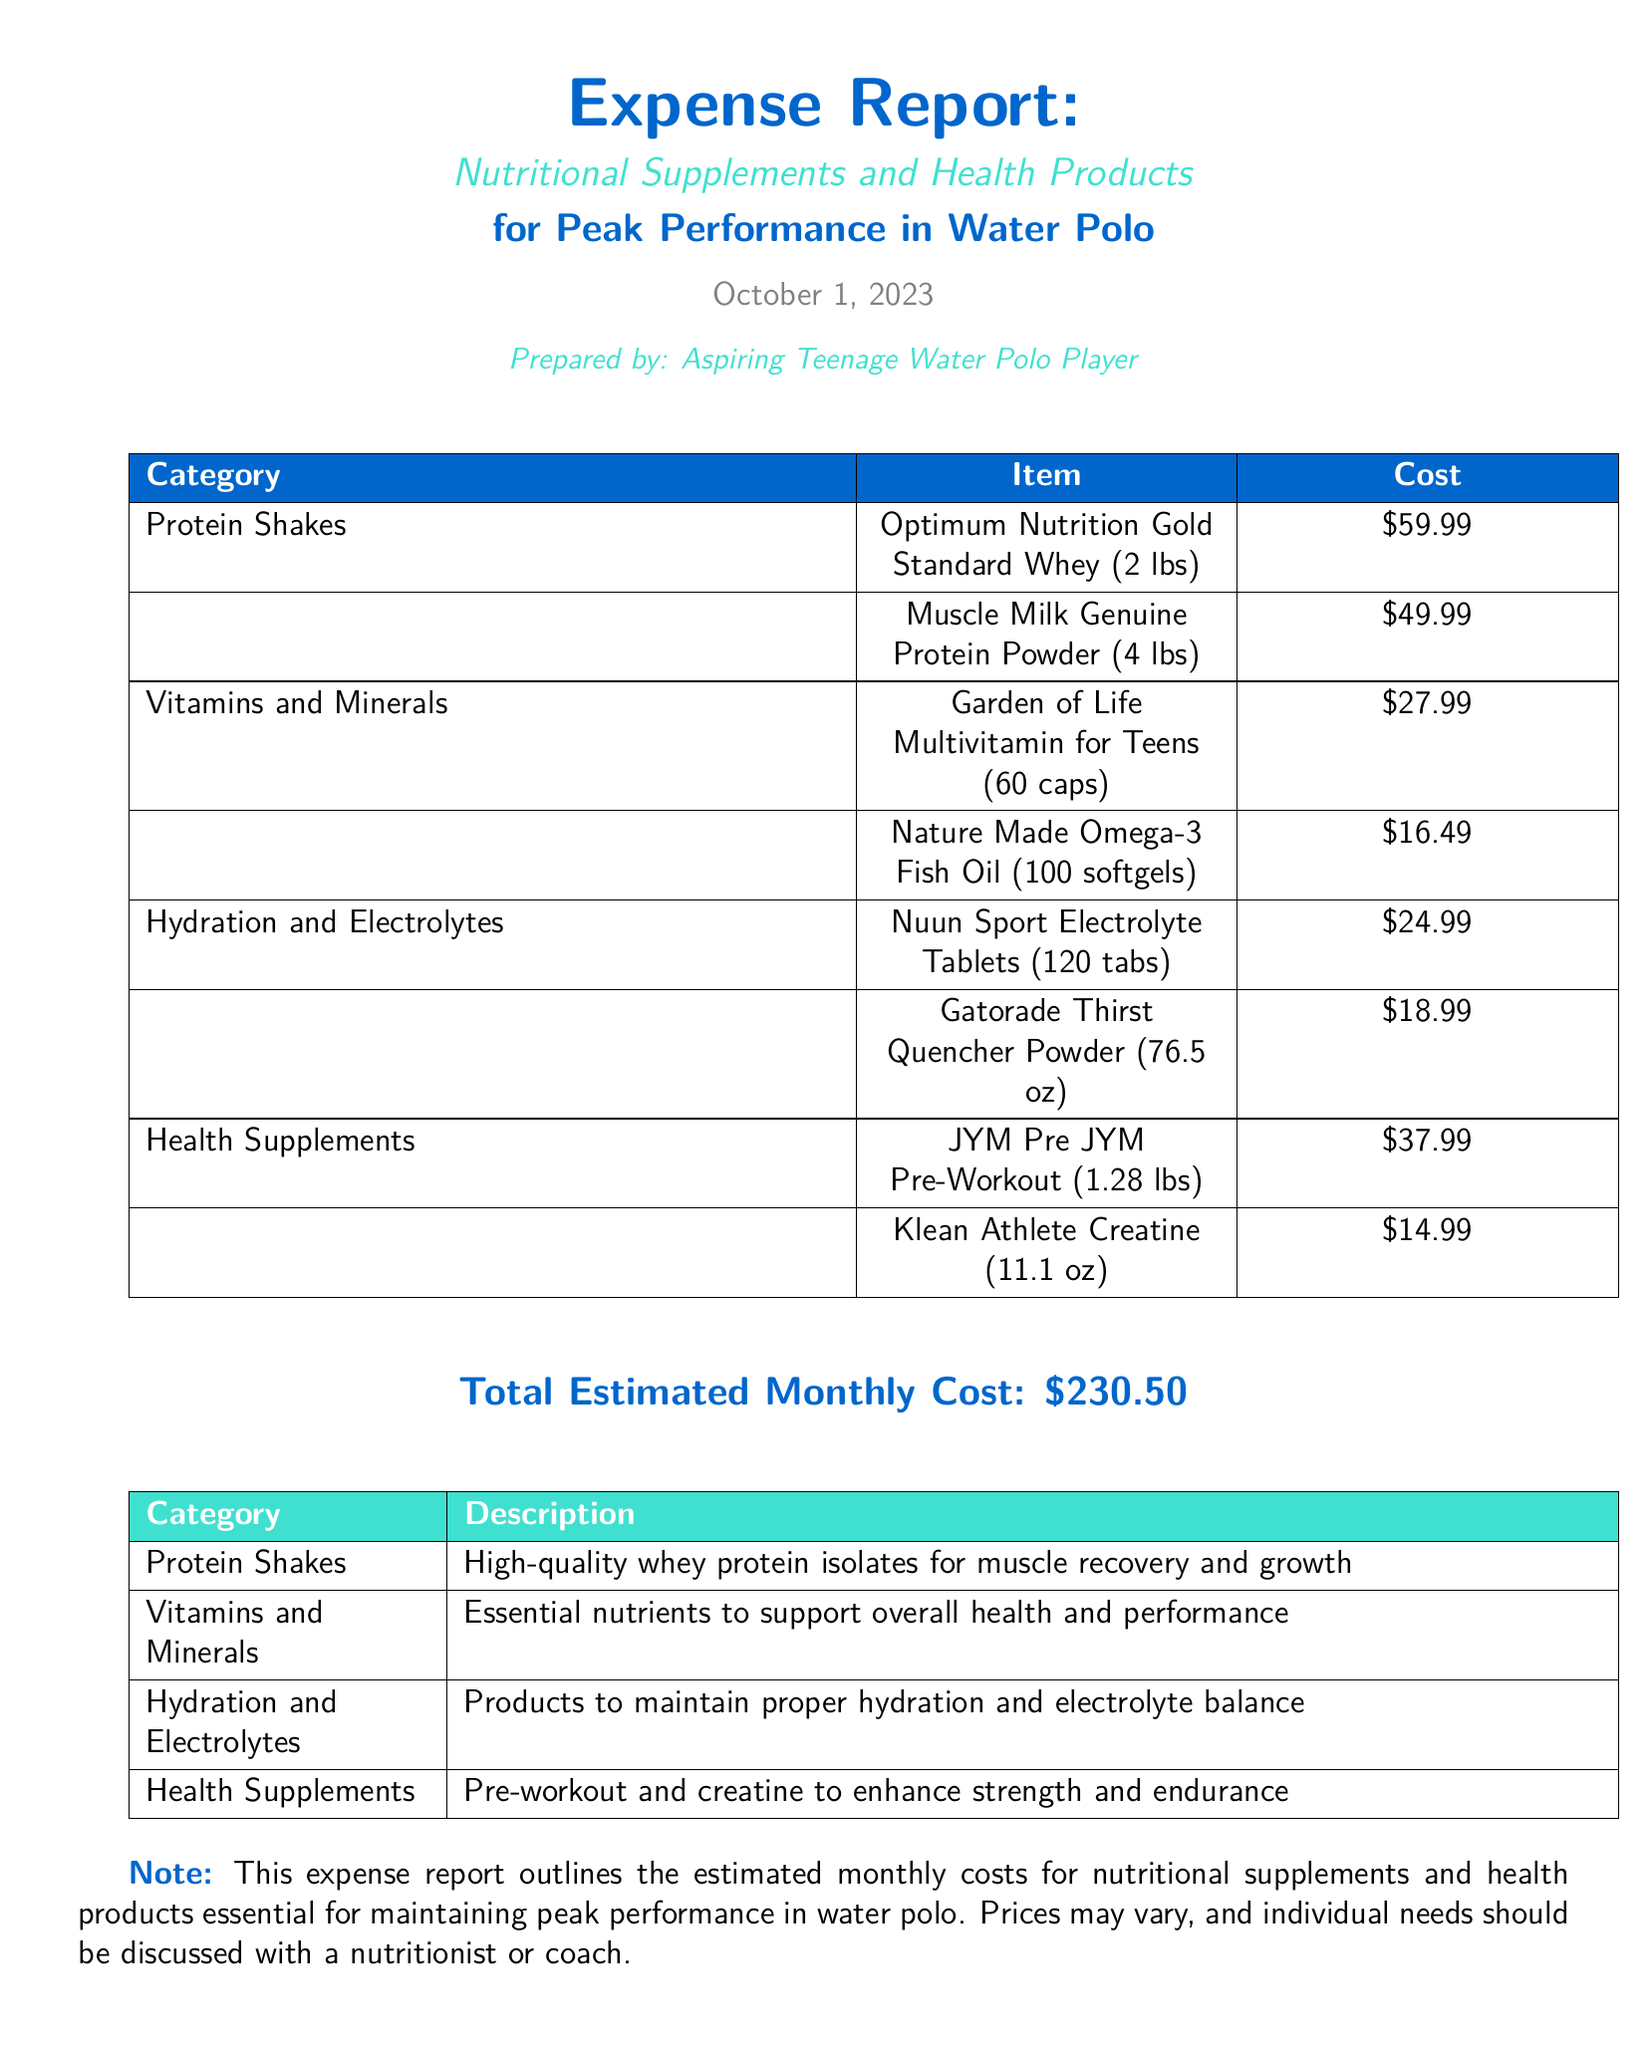What is the total estimated monthly cost? The total estimated monthly cost is mentioned at the bottom of the report as $230.50.
Answer: $230.50 How many ounces is the Klean Athlete Creatine? The Klean Athlete Creatine is listed as 11.1 oz in the health supplements category.
Answer: 11.1 oz What type of multivitamin is included in the report? The report mentions "Garden of Life Multivitamin for Teens" in the vitamins and minerals category.
Answer: Garden of Life Multivitamin for Teens Which protein shake is the most expensive? The protein shake with the highest cost is "Optimum Nutrition Gold Standard Whey (2 lbs)" at $59.99.
Answer: Optimum Nutrition Gold Standard Whey (2 lbs) How many tablets are in the Nuun Sport Electrolyte Tablets? The report states that there are 120 tablets in the Nuun Sport Electrolyte Tablets.
Answer: 120 tabs What is the purpose of the health supplements listed? Health supplements are intended to enhance strength and endurance, as indicated in the report.
Answer: Enhance strength and endurance Who prepared the expense report? The expense report is prepared by an aspiring teenage water polo player, as mentioned at the top of the document.
Answer: Aspiring Teenage Water Polo Player What kind of product is Gatorade Thirst Quencher Powder? Gatorade Thirst Quencher Powder is categorized under Hydration and Electrolytes in the expense report.
Answer: Hydration and Electrolytes 